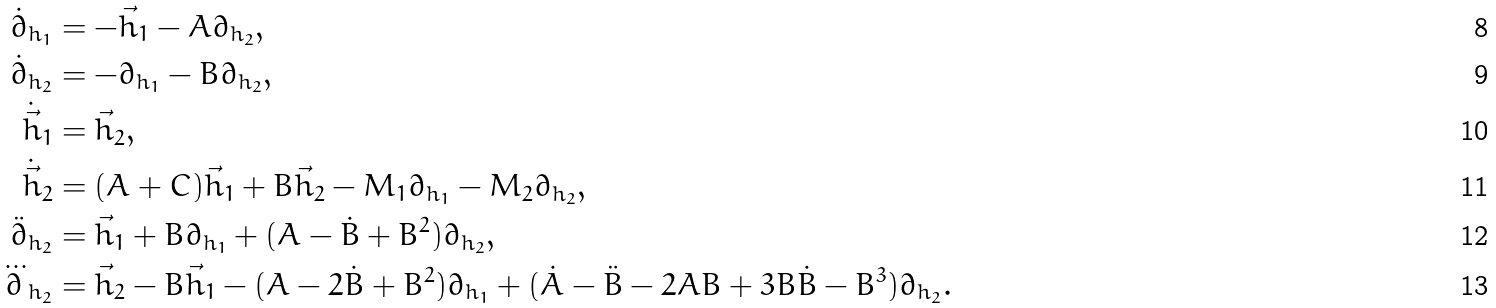Convert formula to latex. <formula><loc_0><loc_0><loc_500><loc_500>\dot { \partial } _ { h _ { 1 } } & = - \vec { h } _ { 1 } - A \partial _ { h _ { 2 } } , \\ \dot { \partial } _ { h _ { 2 } } & = - \partial _ { h _ { 1 } } - B \partial _ { h _ { 2 } } , \\ \dot { \vec { h } } _ { 1 } & = \vec { h } _ { 2 } , \\ \dot { \vec { h } } _ { 2 } & = ( A + C ) \vec { h } _ { 1 } + B \vec { h } _ { 2 } - M _ { 1 } \partial _ { h _ { 1 } } - M _ { 2 } \partial _ { h _ { 2 } } , \\ \ddot { \partial } _ { h _ { 2 } } & = \vec { h } _ { 1 } + B \partial _ { h _ { 1 } } + ( A - \dot { B } + B ^ { 2 } ) \partial _ { h _ { 2 } } , \\ \dddot { \partial } _ { h _ { 2 } } & = \vec { h } _ { 2 } - B \vec { h } _ { 1 } - ( A - 2 \dot { B } + B ^ { 2 } ) \partial _ { h _ { 1 } } + ( \dot { A } - \ddot { B } - 2 A B + 3 B \dot { B } - B ^ { 3 } ) \partial _ { h _ { 2 } } .</formula> 